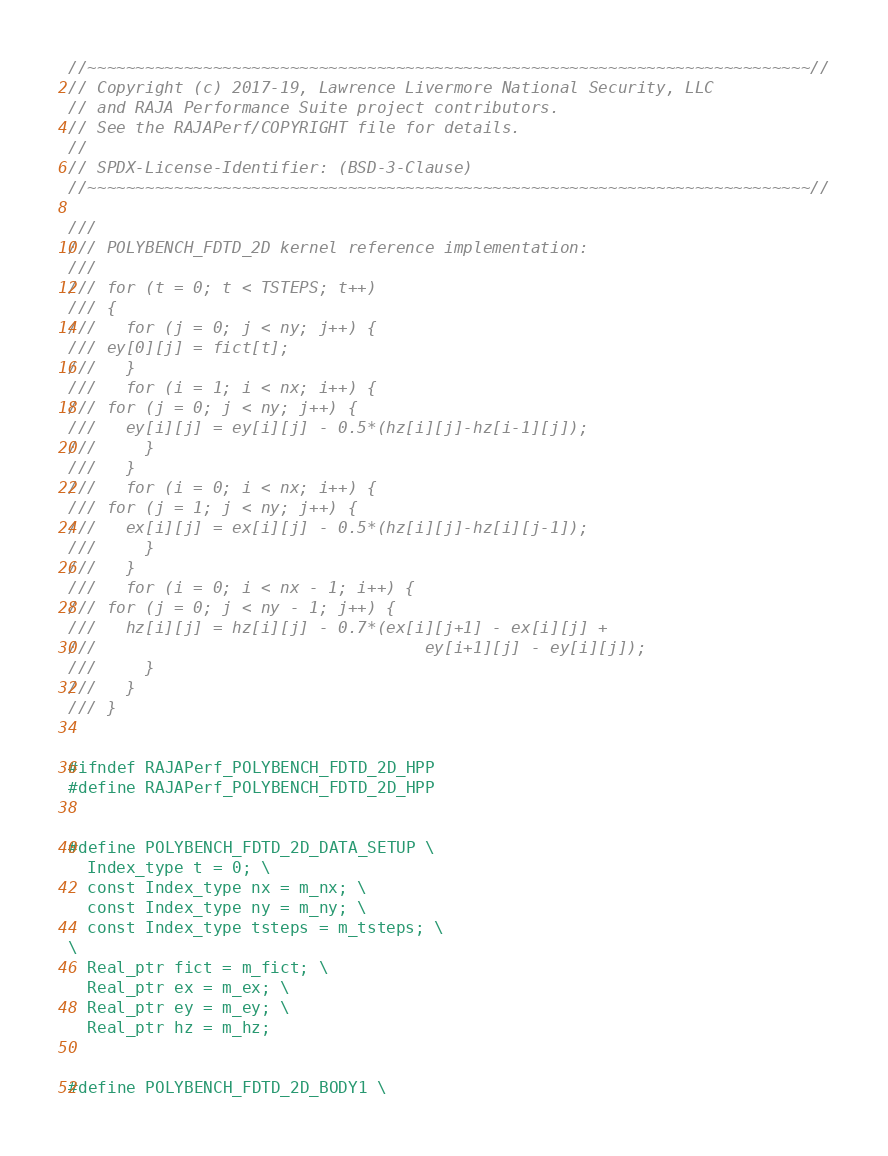<code> <loc_0><loc_0><loc_500><loc_500><_C++_>//~~~~~~~~~~~~~~~~~~~~~~~~~~~~~~~~~~~~~~~~~~~~~~~~~~~~~~~~~~~~~~~~~~~~~~~~~~~//
// Copyright (c) 2017-19, Lawrence Livermore National Security, LLC
// and RAJA Performance Suite project contributors.
// See the RAJAPerf/COPYRIGHT file for details.
//
// SPDX-License-Identifier: (BSD-3-Clause)
//~~~~~~~~~~~~~~~~~~~~~~~~~~~~~~~~~~~~~~~~~~~~~~~~~~~~~~~~~~~~~~~~~~~~~~~~~~~//

///
/// POLYBENCH_FDTD_2D kernel reference implementation:
///
/// for (t = 0; t < TSTEPS; t++)
/// {
///   for (j = 0; j < ny; j++) {
///	ey[0][j] = fict[t];
///   }
///   for (i = 1; i < nx; i++) {
///	for (j = 0; j < ny; j++) {
///	  ey[i][j] = ey[i][j] - 0.5*(hz[i][j]-hz[i-1][j]);
///     }
///   } 
///   for (i = 0; i < nx; i++) {
///	for (j = 1; j < ny; j++) {
///	  ex[i][j] = ex[i][j] - 0.5*(hz[i][j]-hz[i][j-1]);
///     }
///   } 
///   for (i = 0; i < nx - 1; i++) {
///	for (j = 0; j < ny - 1; j++) {
///	  hz[i][j] = hz[i][j] - 0.7*(ex[i][j+1] - ex[i][j] +
///                                  ey[i+1][j] - ey[i][j]);
///     }
///   }
/// }


#ifndef RAJAPerf_POLYBENCH_FDTD_2D_HPP
#define RAJAPerf_POLYBENCH_FDTD_2D_HPP


#define POLYBENCH_FDTD_2D_DATA_SETUP \
  Index_type t = 0; \
  const Index_type nx = m_nx; \
  const Index_type ny = m_ny; \
  const Index_type tsteps = m_tsteps; \
\
  Real_ptr fict = m_fict; \
  Real_ptr ex = m_ex; \
  Real_ptr ey = m_ey; \
  Real_ptr hz = m_hz;


#define POLYBENCH_FDTD_2D_BODY1 \</code> 